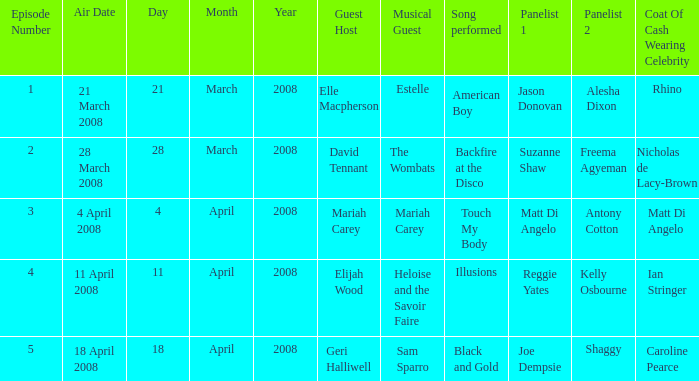Name the least number of episodes for the panelists of reggie yates and kelly osbourne 4.0. 